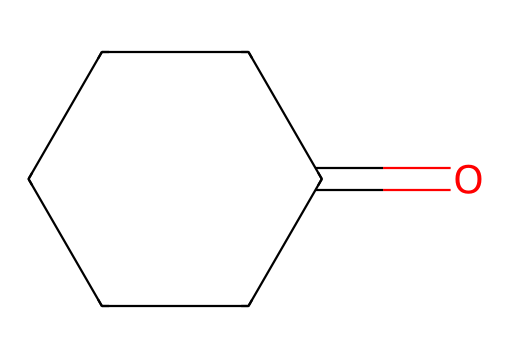What is the name of this chemical? The SMILES representation indicates the chemical is cyclohexanone, which consists of a cyclohexane ring with a ketone functional group.
Answer: cyclohexanone How many carbon atoms are present in this structure? By analyzing the structure derived from the SMILES notation, you can count the carbon atoms in the cyclohexane ring (6) plus the carbon in the ketone group (1), totaling 6.
Answer: 6 What type of functional group is present in cyclohexanone? The presence of the carbonyl group (C=O) in the structure indicates that it is a ketone.
Answer: ketone What is the degree of saturation in this molecule? Considering the structure has only single and one double bond and is a cyclic compound, the degree of saturation (which counts rings and double bonds) is 1, specifically due to the carbonyl group contributing to saturation.
Answer: 1 Which type of reaction can cyclohexanone undergo due to its functional group? As a ketone, cyclohexanone can undergo nucleophilic addition reactions with nucleophiles attacking the carbonyl carbon.
Answer: nucleophilic addition What is the molecular formula of cyclohexanone? Based on the SMILES representation (6 carbon, 10 hydrogen, 1 oxygen), the molecular formula derived from the structure is C6H10O.
Answer: C6H10O 